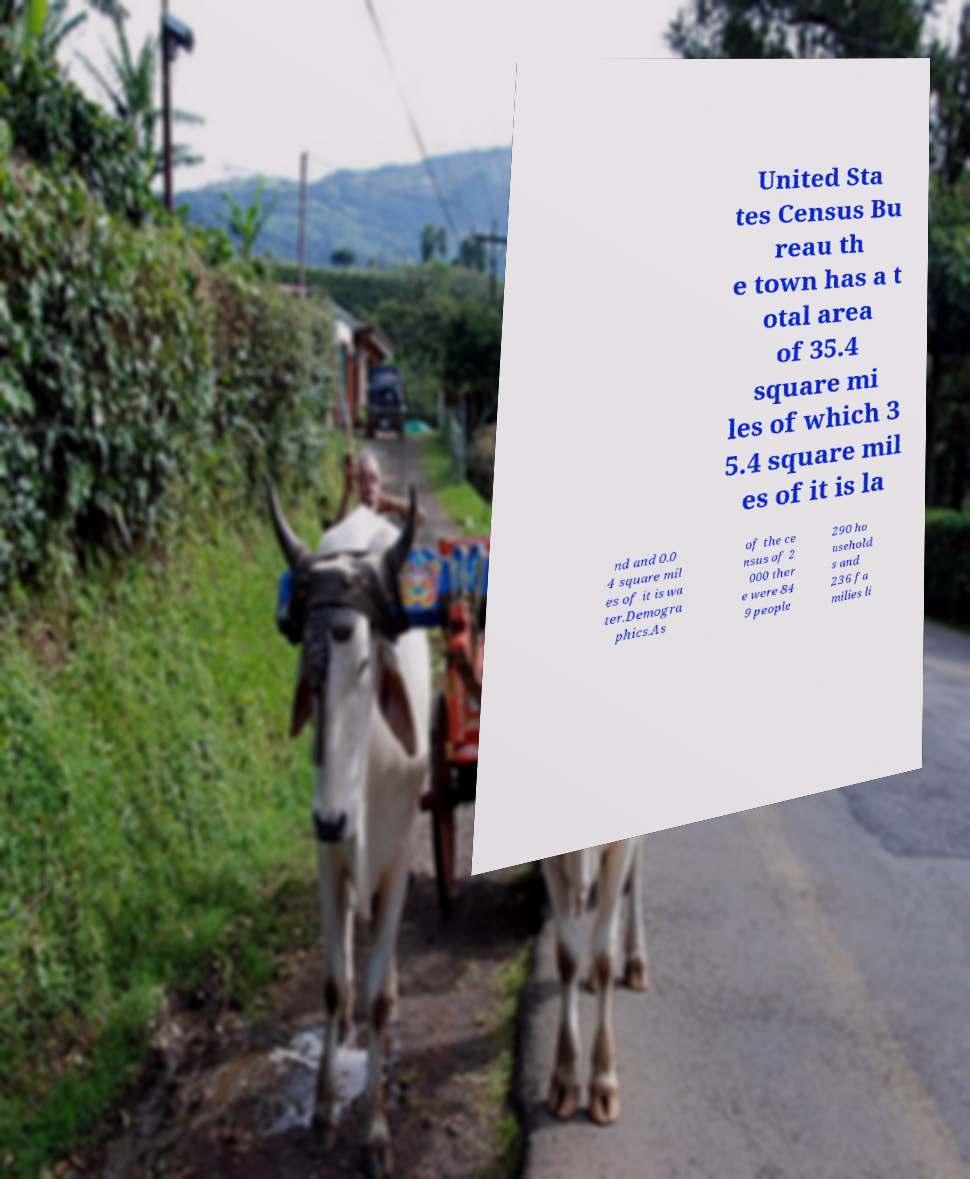Please identify and transcribe the text found in this image. United Sta tes Census Bu reau th e town has a t otal area of 35.4 square mi les of which 3 5.4 square mil es of it is la nd and 0.0 4 square mil es of it is wa ter.Demogra phics.As of the ce nsus of 2 000 ther e were 84 9 people 290 ho usehold s and 236 fa milies li 